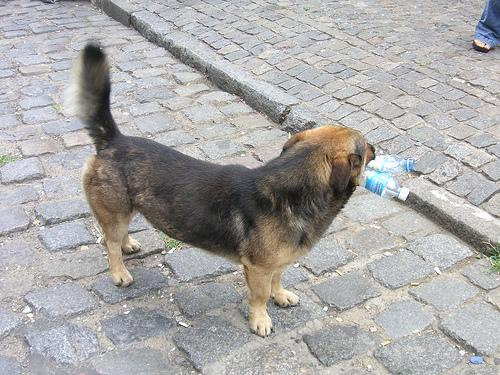Detail the central figure in the image and describe what they are engaged in at the moment. A dog displaying a mix of black and brown colors stands confidently on a bricked road, adeptly holding two water bottles with its mouth. Summarize the key subject in the image and the activity they are participating in. A black and orange dog is standing on cobblestones, with a pair of water bottles securely held in its mouth. Provide a concise description of the image's primary subject and their actions. A dog with black and brown fur stands on a bricked pavement, carrying two plastic water bottles in its mouth. In a short sentence, explain the main subject of the image and their current actions. A dog with fur of black and brown hues is gripping two water bottles in its mouth while standing on a cobblestone pathway. Quickly describe the image's primary theme and any evident activity. A brown and black dog positions itself on a bricked path, holding two water bottles in its mouth during the daylight. Identify the central focus of the image and what is happening. A black and brown dog is standing on a cobblestone path, holding two water bottles in its mouth, during daytime. Briefly describe the main elements of the image and the activity taking place. On a cobblestone street, a black and brown dog holds two water bottles between its jaws. Give a brief account of the primary character in the image and their ongoing actions. A black-brown canine stands firmly on a paved road, skillfully holding two water bottles using its mouth. Communicate the image's main subject and the events taking place. The black and brown dog, standing on a cobblestone street, has two water bottles in its mouth, all while basking in the sunlight. Characterize the main object in the image and the actions they are performing currently. A dog exhibiting black and brown fur stands on a cobblestone trail, expertly gripping two plastic water bottles in its jaw. 